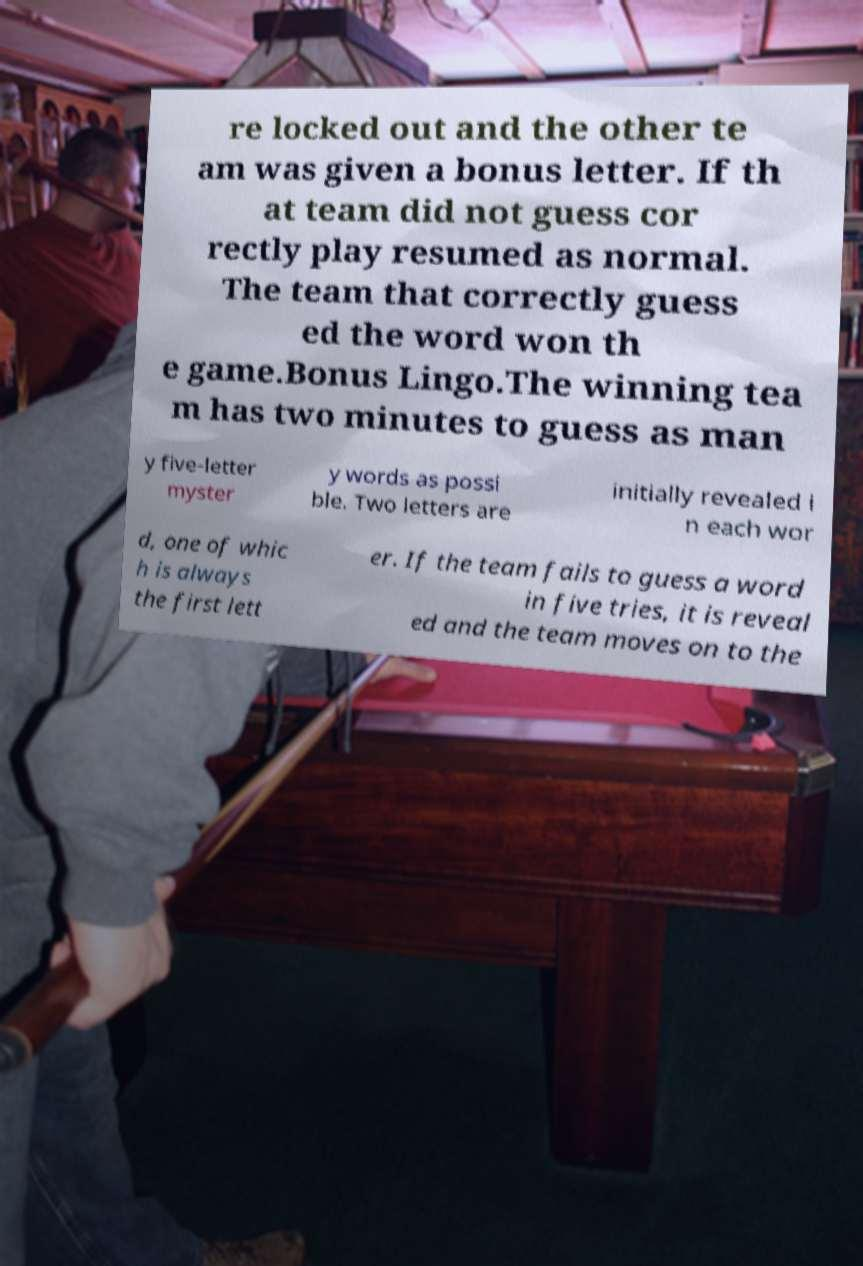Can you accurately transcribe the text from the provided image for me? re locked out and the other te am was given a bonus letter. If th at team did not guess cor rectly play resumed as normal. The team that correctly guess ed the word won th e game.Bonus Lingo.The winning tea m has two minutes to guess as man y five-letter myster y words as possi ble. Two letters are initially revealed i n each wor d, one of whic h is always the first lett er. If the team fails to guess a word in five tries, it is reveal ed and the team moves on to the 